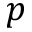<formula> <loc_0><loc_0><loc_500><loc_500>p</formula> 